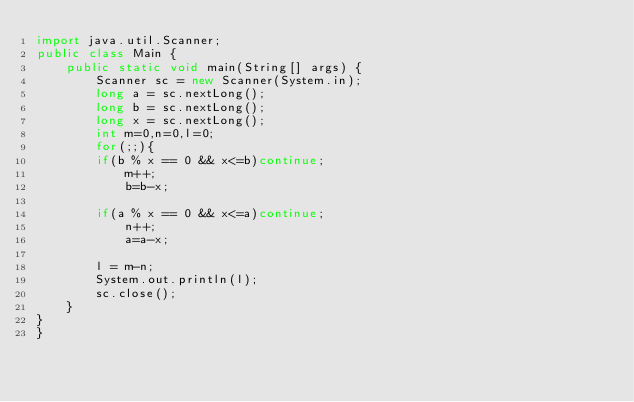Convert code to text. <code><loc_0><loc_0><loc_500><loc_500><_Java_>import java.util.Scanner;
public class Main {
	public static void main(String[] args) {
		Scanner sc = new Scanner(System.in);
		long a = sc.nextLong();
		long b = sc.nextLong();
		long x = sc.nextLong();
		int m=0,n=0,l=0;
		for(;;){
		if(b % x == 0 && x<=b)continue;
		    m++;
		    b=b-x;
		
		if(a % x == 0 && x<=a)continue;
			n++;
			a=a-x;
	
		l = m-n;
		System.out.println(l);
		sc.close();
	}
}
}</code> 